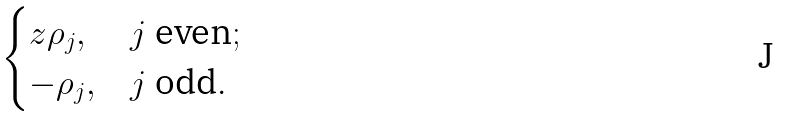<formula> <loc_0><loc_0><loc_500><loc_500>\begin{cases} z \rho _ { j } , & j \text { even} ; \\ - \rho _ { j } , & j \text { odd} . \end{cases}</formula> 